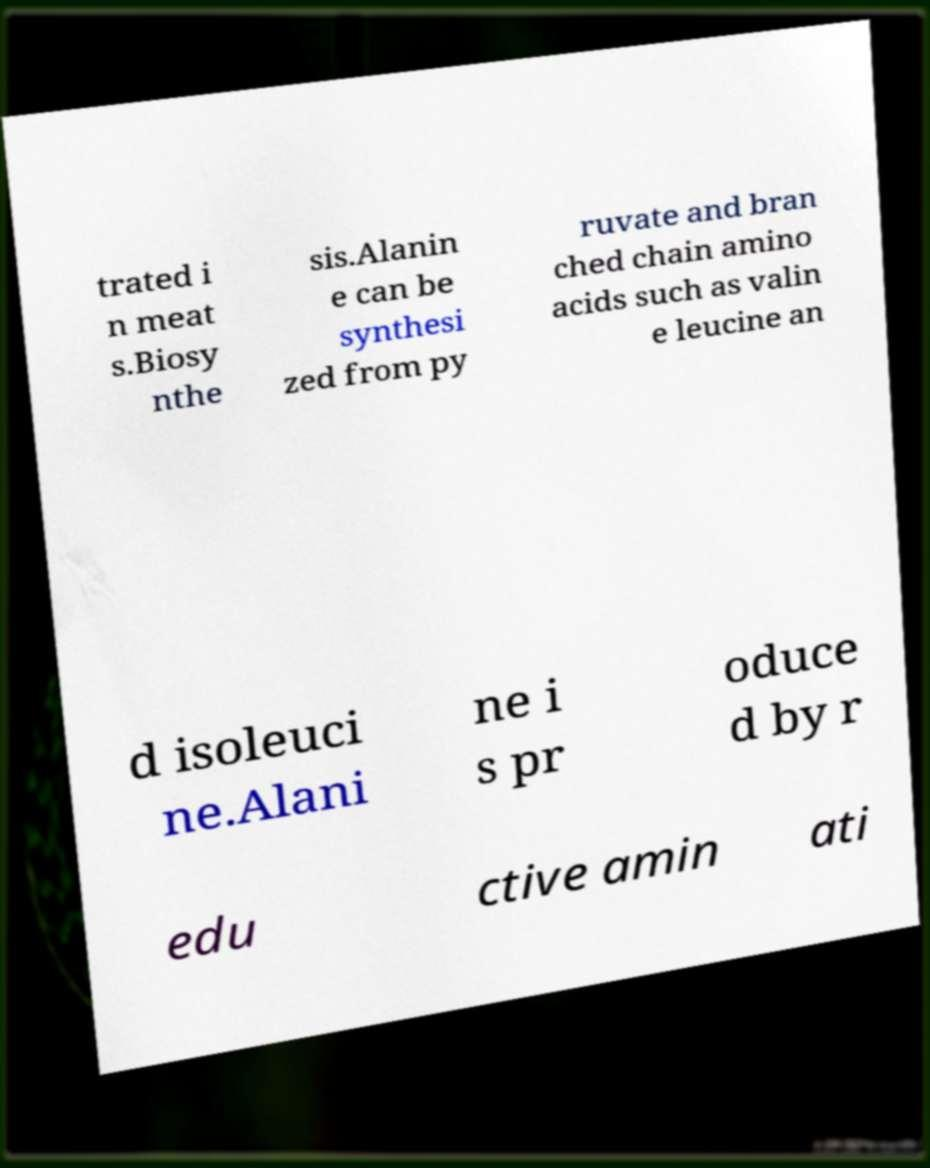What messages or text are displayed in this image? I need them in a readable, typed format. trated i n meat s.Biosy nthe sis.Alanin e can be synthesi zed from py ruvate and bran ched chain amino acids such as valin e leucine an d isoleuci ne.Alani ne i s pr oduce d by r edu ctive amin ati 